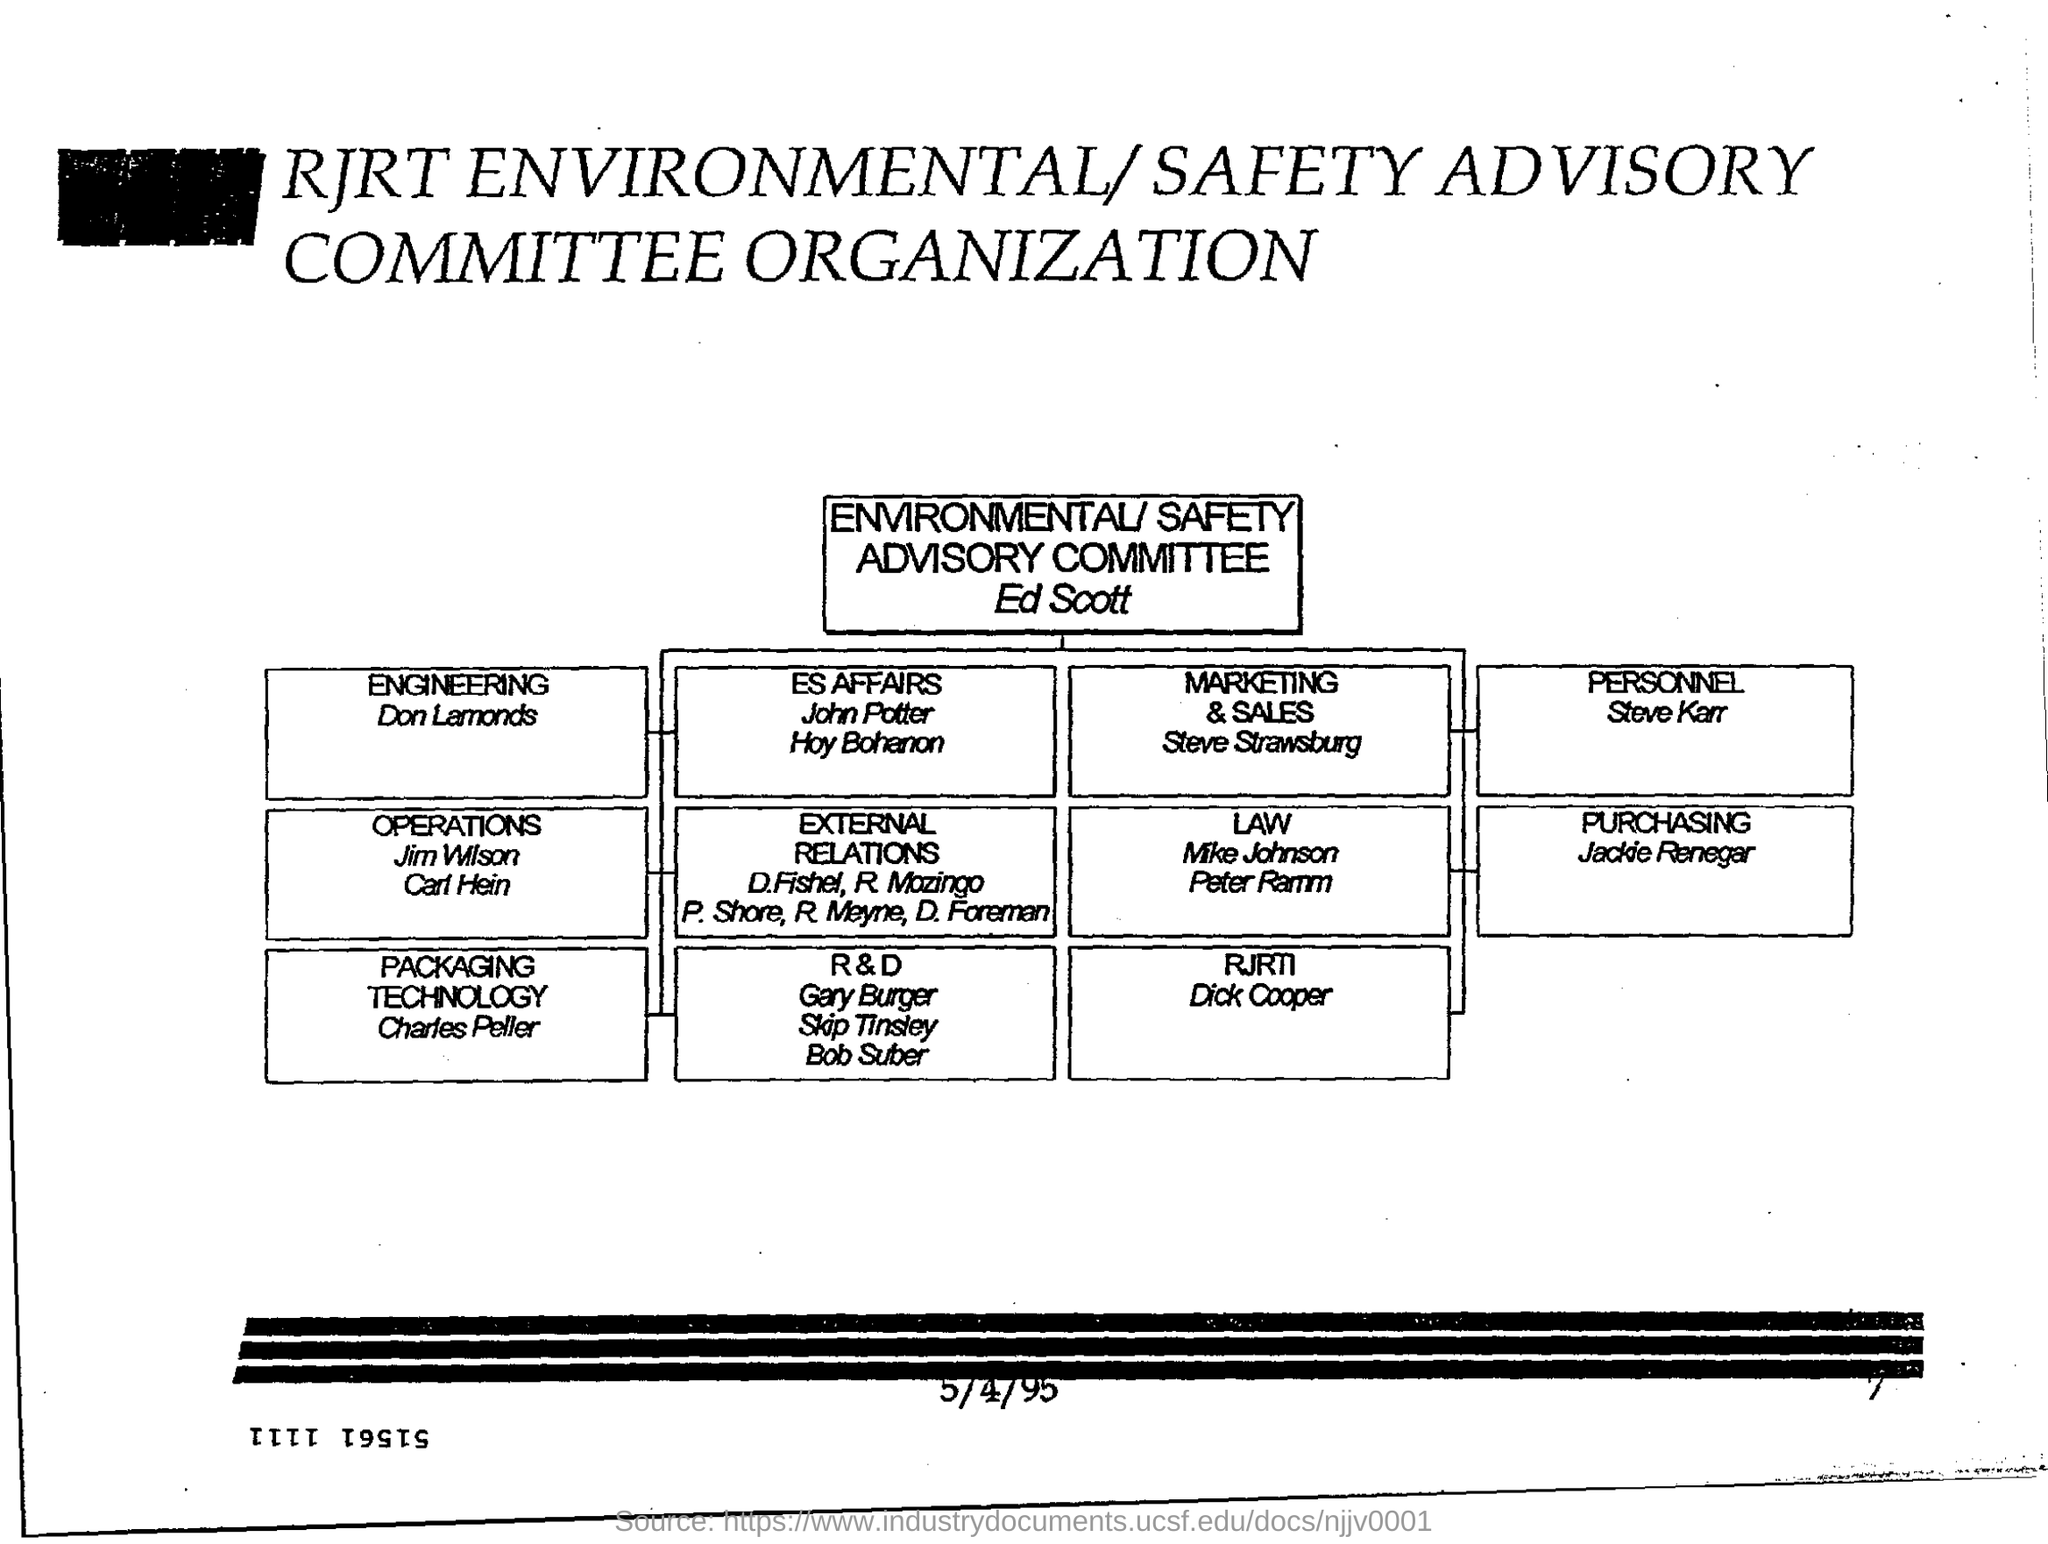Highlight a few significant elements in this photo. The responsibility for personnel is taken care of by Steve Karr. Steve Strawsburg is a member of the Marketing & Sales department. The head of the environmental/safety advisory committee is Ed Scott. The person named Charles Peller is a member of the Packaging technology. 